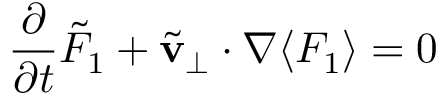Convert formula to latex. <formula><loc_0><loc_0><loc_500><loc_500>\frac { \partial } { \partial t } \tilde { F } _ { 1 } + \tilde { v } _ { \perp } \cdot { \boldsymbol \nabla } \langle F _ { 1 } \rangle = 0</formula> 